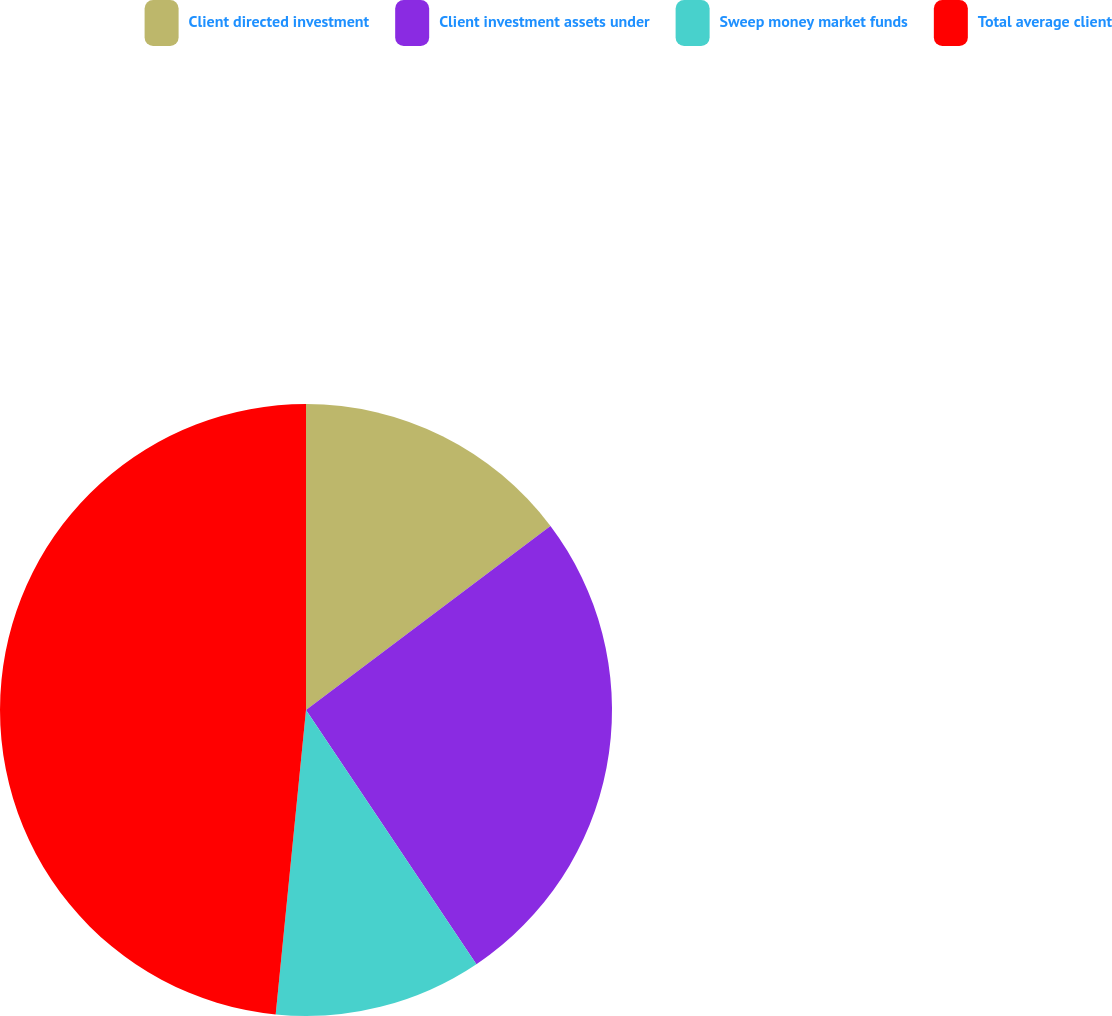<chart> <loc_0><loc_0><loc_500><loc_500><pie_chart><fcel>Client directed investment<fcel>Client investment assets under<fcel>Sweep money market funds<fcel>Total average client<nl><fcel>14.73%<fcel>25.87%<fcel>10.98%<fcel>48.42%<nl></chart> 